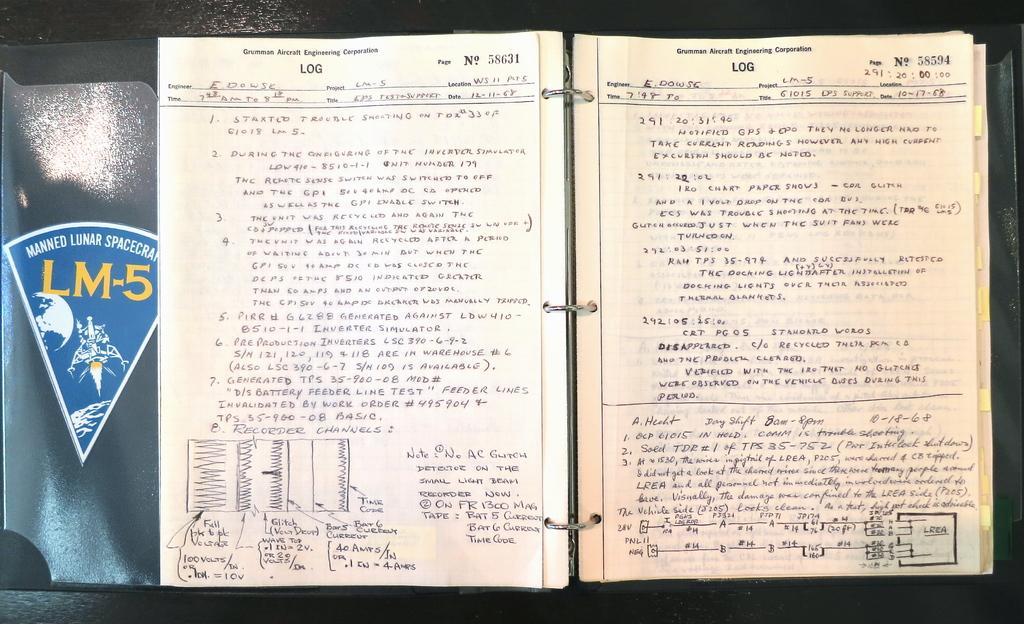<image>
Describe the image concisely. A three-ring binder has a sticker showing the LM-5 lunar spacecraft. 